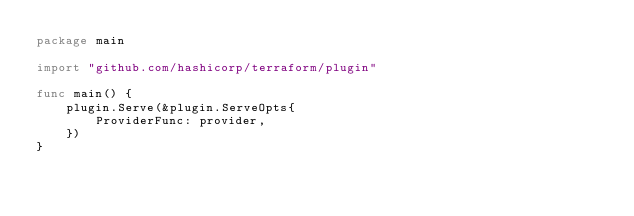<code> <loc_0><loc_0><loc_500><loc_500><_Go_>package main

import "github.com/hashicorp/terraform/plugin"

func main() {
	plugin.Serve(&plugin.ServeOpts{
		ProviderFunc: provider,
	})
}
</code> 